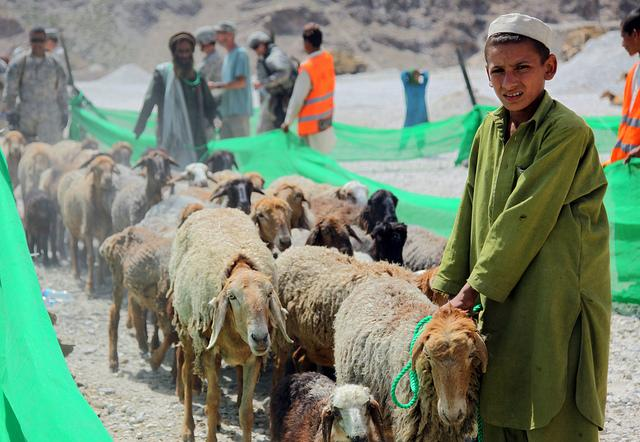Why are the men's vests orange in color? Please explain your reasoning. visibility. The vests are visible. 